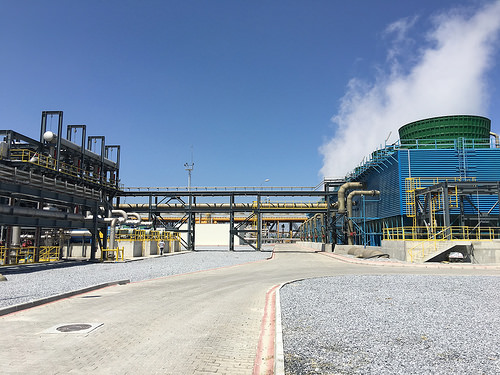<image>
Is the building on the concrete? No. The building is not positioned on the concrete. They may be near each other, but the building is not supported by or resting on top of the concrete. 